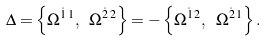<formula> <loc_0><loc_0><loc_500><loc_500>\Delta = \left \{ \Omega ^ { \dot { 1 } \, 1 } , \ \Omega ^ { \dot { 2 } \, 2 } \right \} = - \left \{ \Omega ^ { \dot { 1 } \, 2 } , \ \Omega ^ { \dot { 2 } \, 1 } \right \} .</formula> 